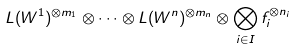<formula> <loc_0><loc_0><loc_500><loc_500>L ( W ^ { 1 } ) ^ { \otimes m _ { 1 } } \otimes \cdots \otimes L ( W ^ { n } ) ^ { \otimes m _ { n } } \otimes \bigotimes _ { i \in I } f _ { i } ^ { \otimes n _ { i } }</formula> 